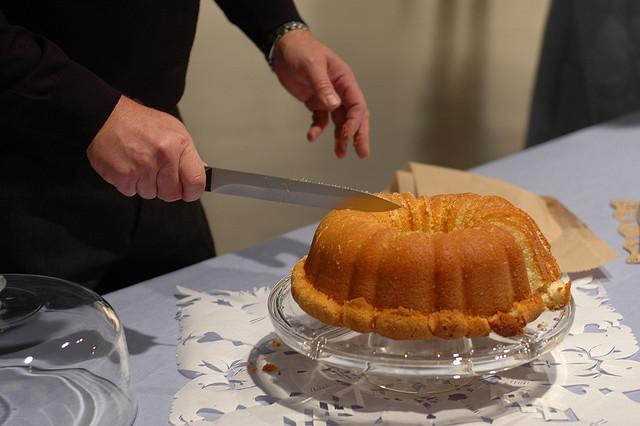What type of cake is this?

Choices:
A) garash cake
B) circle cake
C) cupcake
D) bondt cake bondt cake 